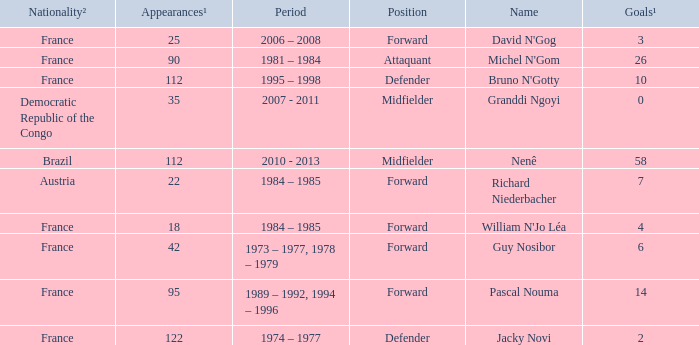How many players are from the country of Brazil? 1.0. 